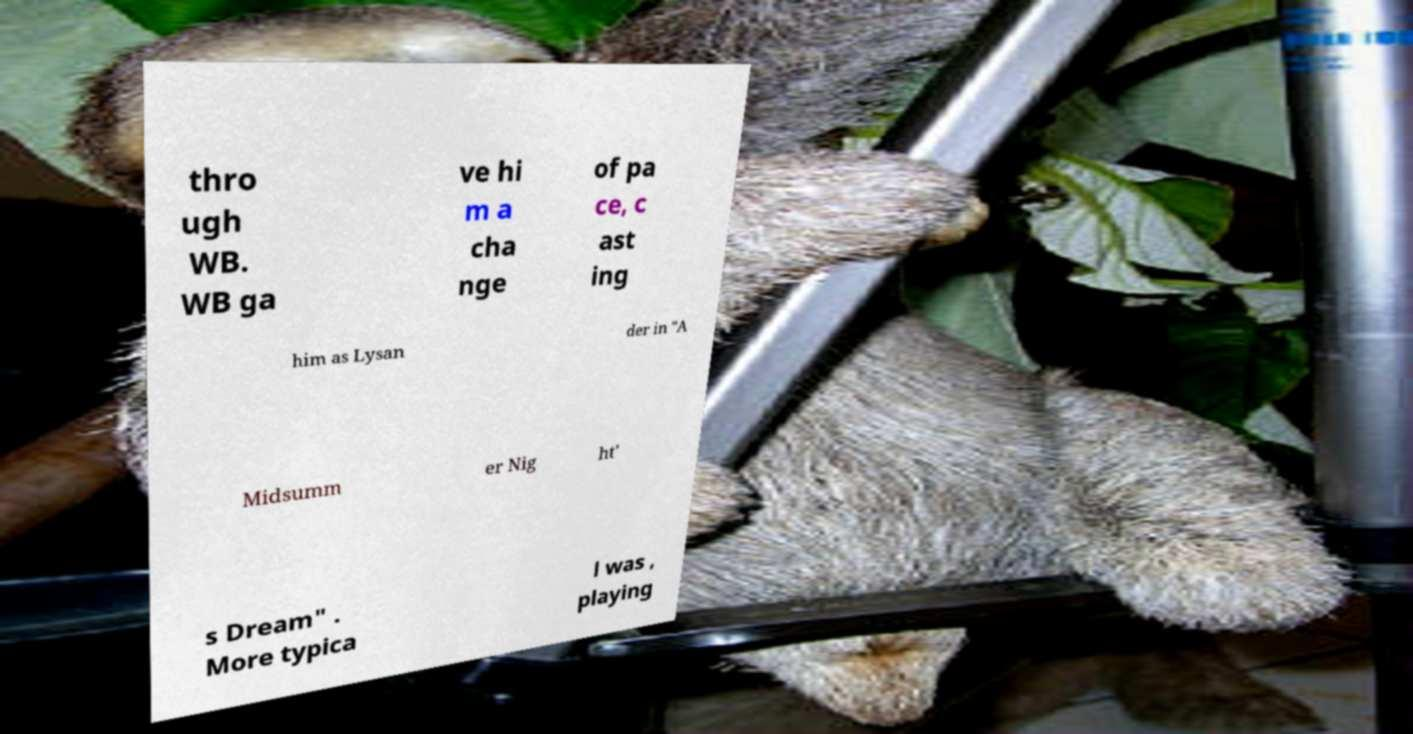What messages or text are displayed in this image? I need them in a readable, typed format. thro ugh WB. WB ga ve hi m a cha nge of pa ce, c ast ing him as Lysan der in "A Midsumm er Nig ht' s Dream" . More typica l was , playing 